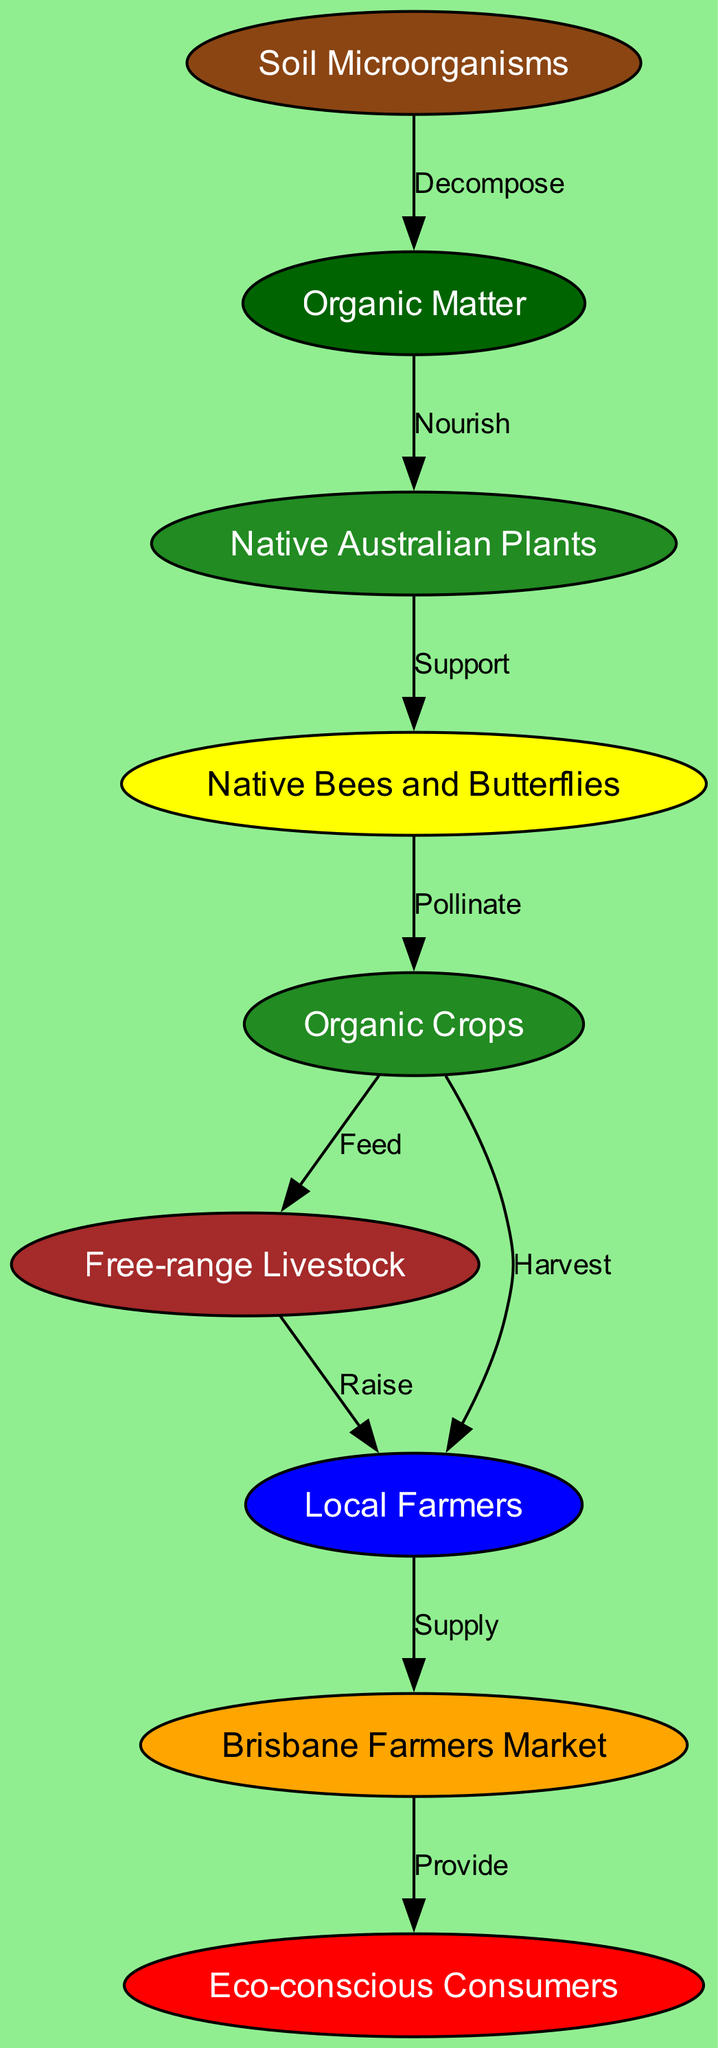What do soil microorganisms decompose? The diagram shows that soil microorganisms decompose organic matter, as indicated by the directed edge labeled "Decompose."
Answer: Organic Matter What do native Australian plants nourish? According to the diagram, organic matter nourishes native Australian plants, as shown by the edge labeled "Nourish."
Answer: Native Australian Plants How many nodes are in the diagram? By counting the list of nodes presented in the diagram, there are a total of 9 nodes.
Answer: 9 Which entity supplies the Brisbane Farmers Market? The directed edge labeled "Supply" indicates that local farmers supply the Brisbane Farmers Market.
Answer: Local Farmers How do native bees and butterflies contribute to the food chain? The diagram shows that native bees and butterflies support native Australian plants, as indicated by the edge labeled "Support." This relationship is essential for the next steps of pollination.
Answer: Support What is the output of organic crops in the food chain? The diagram illustrates that organic crops have two outputs: they feed free-range livestock and are harvested by local farmers, as indicated by the edges labeled "Feed" and "Harvest."
Answer: Free-range Livestock and Local Farmers How do pollinators interact with crops? The diagram depicts that pollinators, such as native bees and butterflies, pollinate organic crops, which is shown by the edge labeled "Pollinate."
Answer: Pollinate Which group of consumers receives products from the Brisbane Farmers Market? The diagram indicates that eco-conscious consumers receive products provided by the Brisbane Farmers Market, as illustrated by the edge labeled "Provide."
Answer: Eco-conscious Consumers What connects farmers to livestock in this food chain? The relationship is established through the edge labeled "Raise," indicating that farmers raise free-range livestock, thereby connecting the two entities in the food chain.
Answer: Raise 